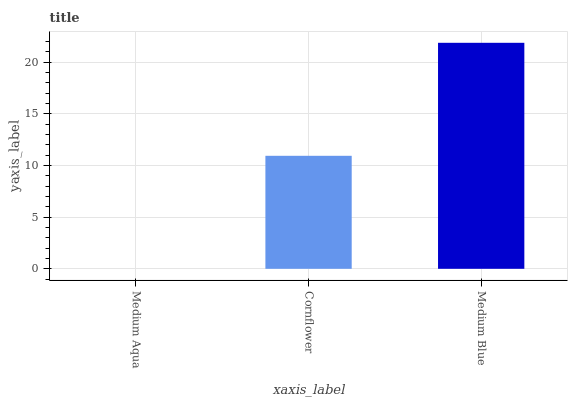Is Cornflower the minimum?
Answer yes or no. No. Is Cornflower the maximum?
Answer yes or no. No. Is Cornflower greater than Medium Aqua?
Answer yes or no. Yes. Is Medium Aqua less than Cornflower?
Answer yes or no. Yes. Is Medium Aqua greater than Cornflower?
Answer yes or no. No. Is Cornflower less than Medium Aqua?
Answer yes or no. No. Is Cornflower the high median?
Answer yes or no. Yes. Is Cornflower the low median?
Answer yes or no. Yes. Is Medium Blue the high median?
Answer yes or no. No. Is Medium Blue the low median?
Answer yes or no. No. 